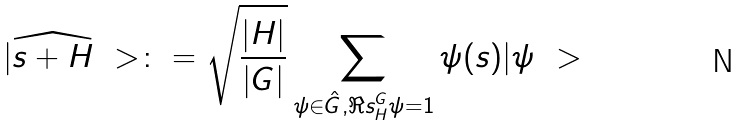Convert formula to latex. <formula><loc_0><loc_0><loc_500><loc_500>| \widehat { s + H } \ > \colon = \sqrt { \frac { | H | } { | G | } } \sum _ { \psi \in \hat { G } , \Re s ^ { G } _ { H } \psi = 1 } \psi ( s ) | \psi \ ></formula> 